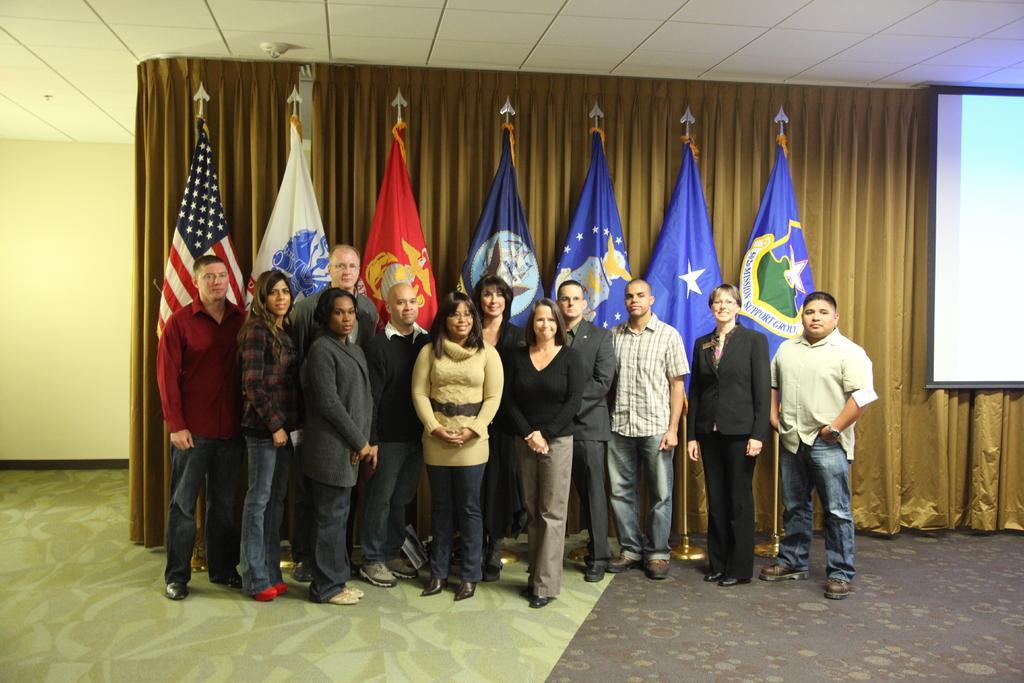In one or two sentences, can you explain what this image depicts? In this image, we can see a group of people are standing on the floor. They are watching. Here we can see few people are smiling. Background we can see curtain, flags, rod stands and wall. On the right side of the image, we can see the screen. Top of the image, there is a ceiling. 